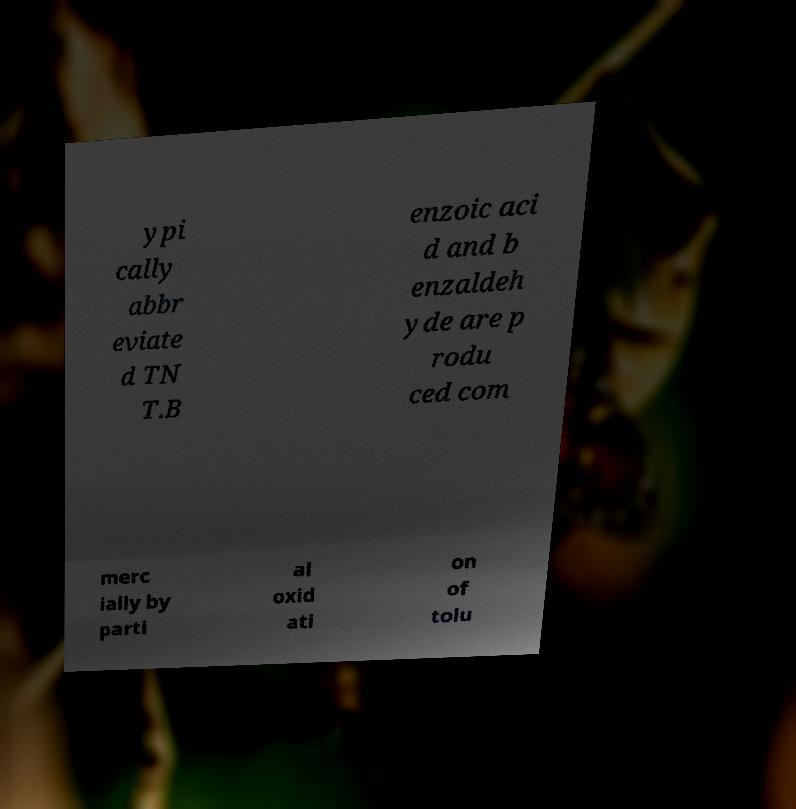Could you assist in decoding the text presented in this image and type it out clearly? ypi cally abbr eviate d TN T.B enzoic aci d and b enzaldeh yde are p rodu ced com merc ially by parti al oxid ati on of tolu 